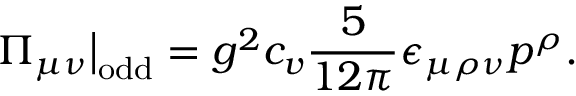Convert formula to latex. <formula><loc_0><loc_0><loc_500><loc_500>\Pi _ { \mu \nu } \Big | _ { o d d } = g ^ { 2 } c _ { v } \frac { 5 } { 1 2 \pi } \epsilon _ { \mu \rho \nu } p ^ { \rho } .</formula> 